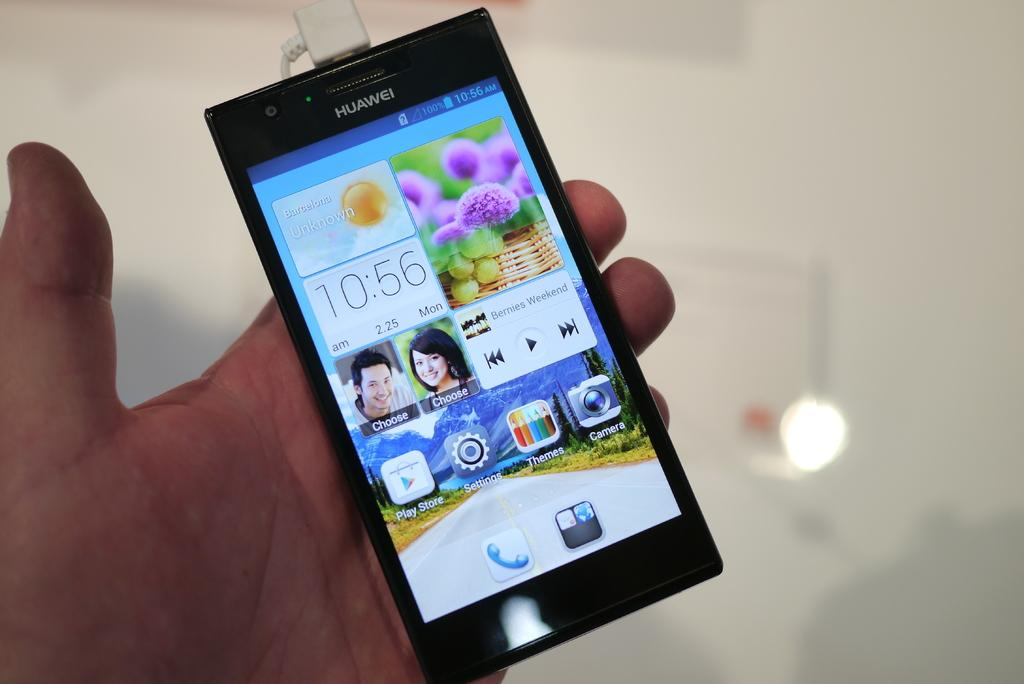<image>
Present a compact description of the photo's key features. A person is holding a cell phone that says Huawei. 